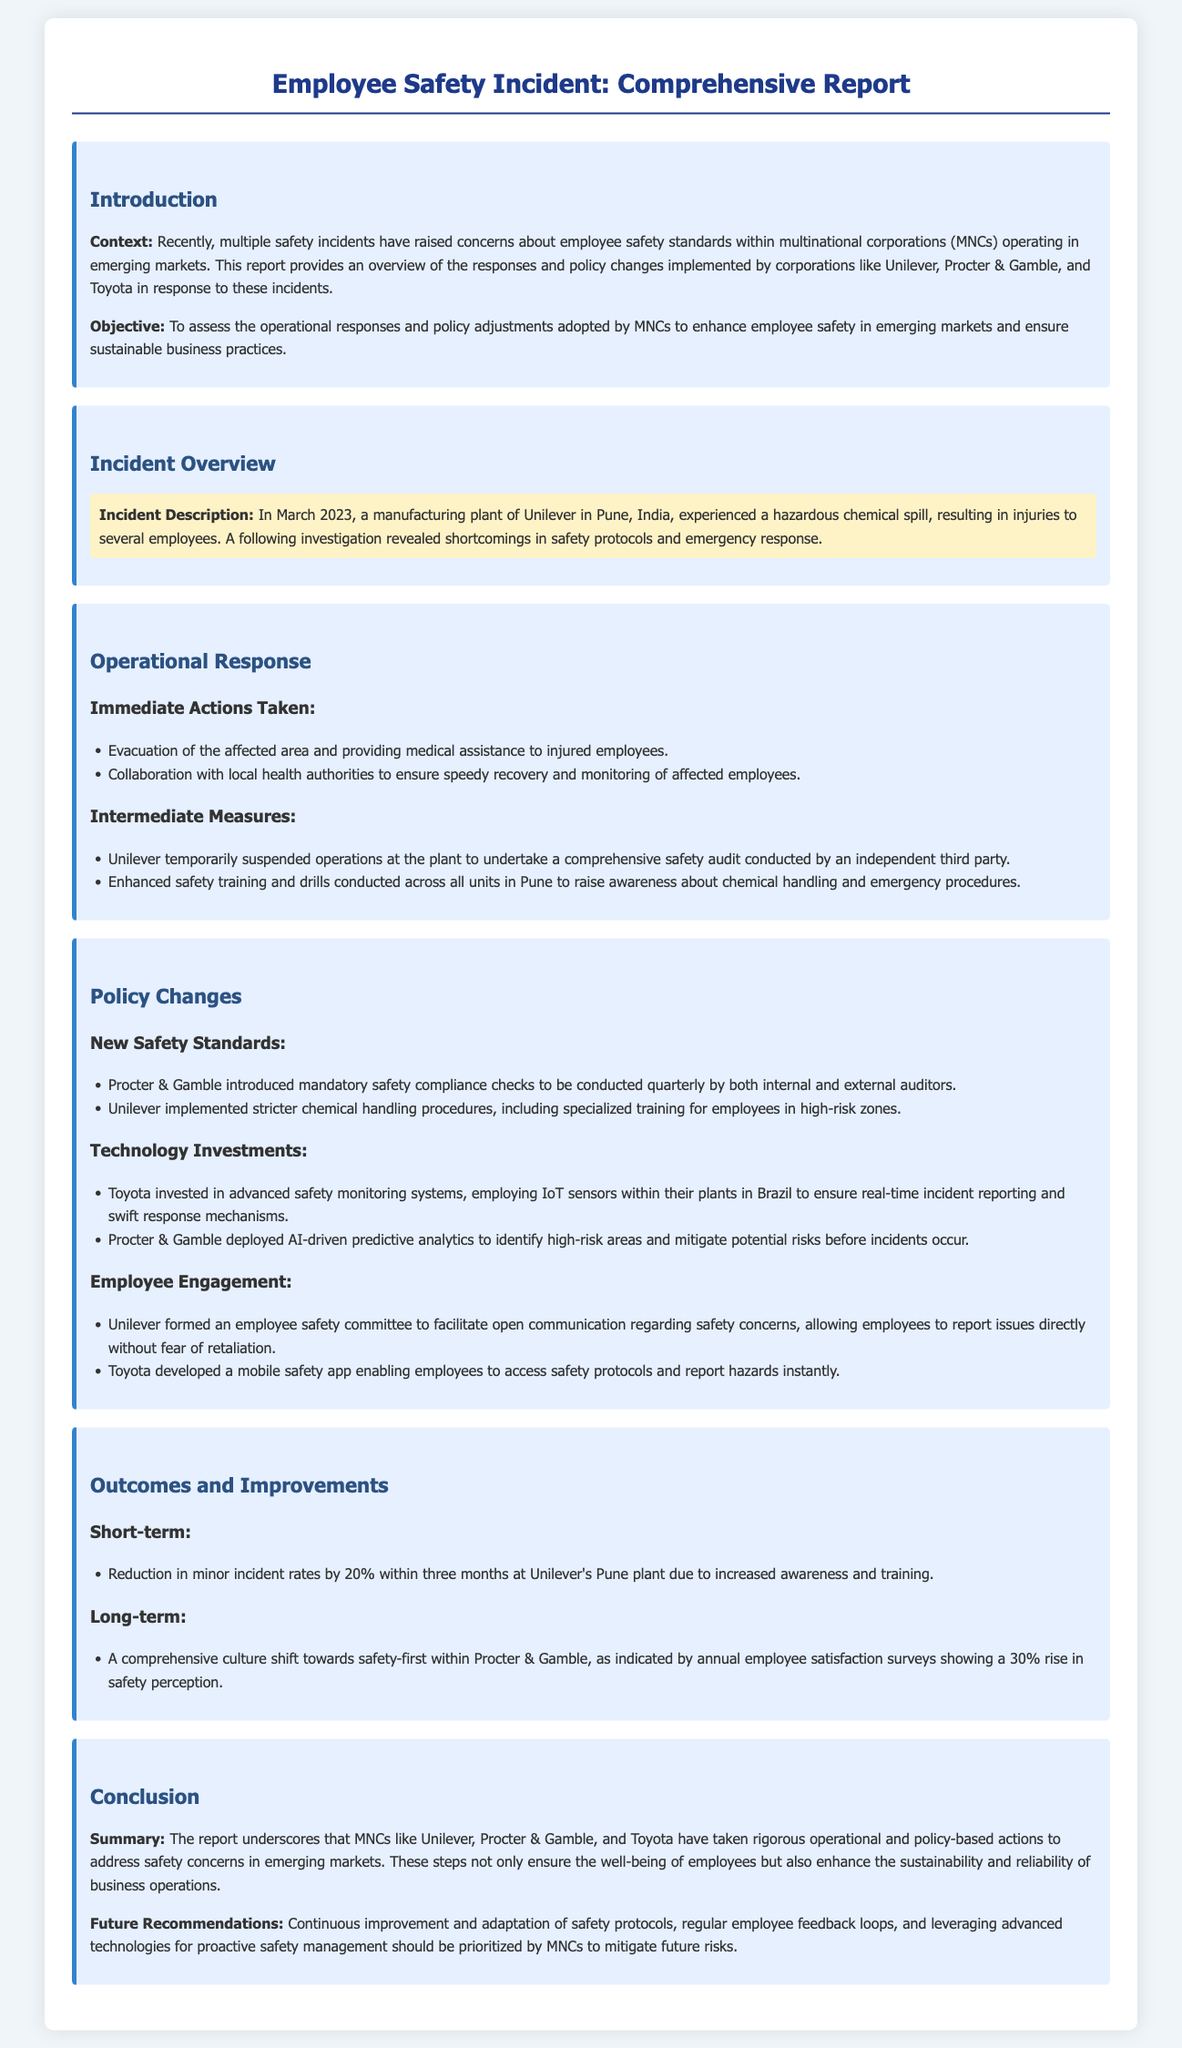What incident occurred at Unilever's plant? The incident involved a hazardous chemical spill resulting in injuries to several employees.
Answer: hazardous chemical spill When did the incident at Unilever occur? The incident took place in March 2023.
Answer: March 2023 What immediate action was taken after the incident? One immediate action taken was the evacuation of the affected area and providing medical assistance to injured employees.
Answer: evacuation and medical assistance Which company deployed AI-driven predictive analytics? The company that deployed AI-driven predictive analytics is Procter & Gamble.
Answer: Procter & Gamble What was the percentage reduction in minor incident rates at Unilever's Pune plant? The reduction in minor incident rates was 20%.
Answer: 20% What new employee engagement strategy did Unilever implement? Unilever formed an employee safety committee to facilitate open communication regarding safety concerns.
Answer: employee safety committee What long-term outcome was indicated by Procter & Gamble's annual employee satisfaction surveys? The surveys indicated a 30% rise in safety perception.
Answer: 30% rise What technological investment did Toyota make for safety monitoring? Toyota invested in advanced safety monitoring systems employing IoT sensors.
Answer: IoT sensors What is a key recommendation for MNCs moving forward? A key recommendation is to prioritize continuous improvement and adaptation of safety protocols.
Answer: continuous improvement and adaptation of safety protocols 